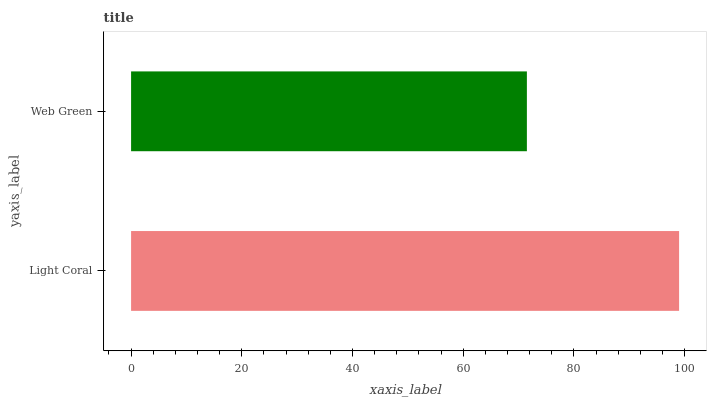Is Web Green the minimum?
Answer yes or no. Yes. Is Light Coral the maximum?
Answer yes or no. Yes. Is Web Green the maximum?
Answer yes or no. No. Is Light Coral greater than Web Green?
Answer yes or no. Yes. Is Web Green less than Light Coral?
Answer yes or no. Yes. Is Web Green greater than Light Coral?
Answer yes or no. No. Is Light Coral less than Web Green?
Answer yes or no. No. Is Light Coral the high median?
Answer yes or no. Yes. Is Web Green the low median?
Answer yes or no. Yes. Is Web Green the high median?
Answer yes or no. No. Is Light Coral the low median?
Answer yes or no. No. 